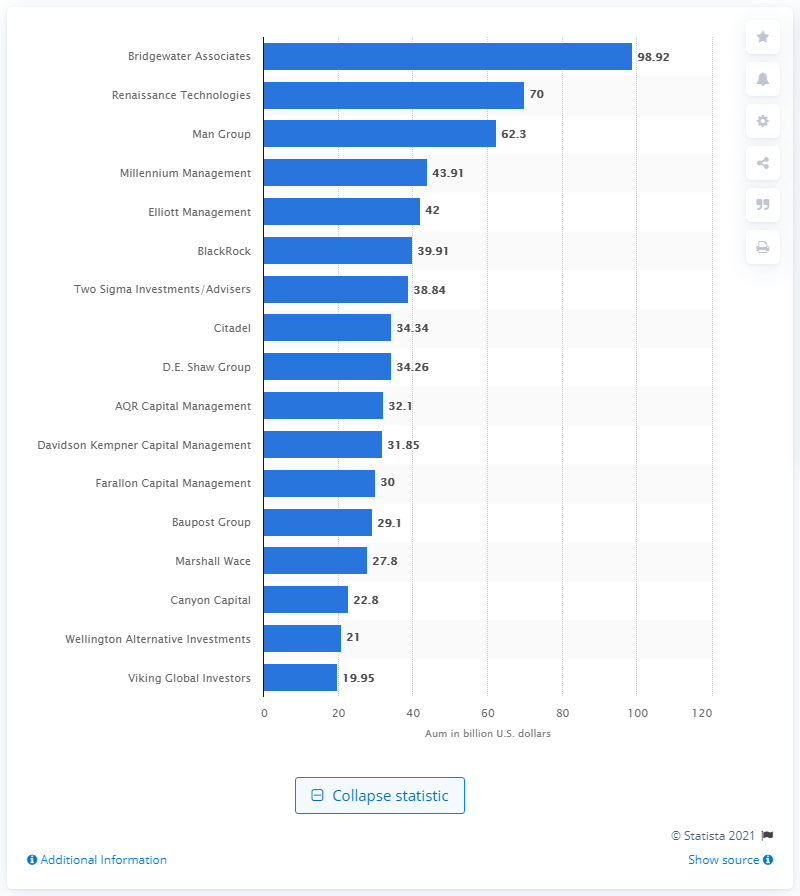Highlight a few significant elements in this photo. Bridgewater Associates' assets were worth $98.92 in dollars. Bridgewater Associates was the largest hedge fund firm in the world as of June 2020. 